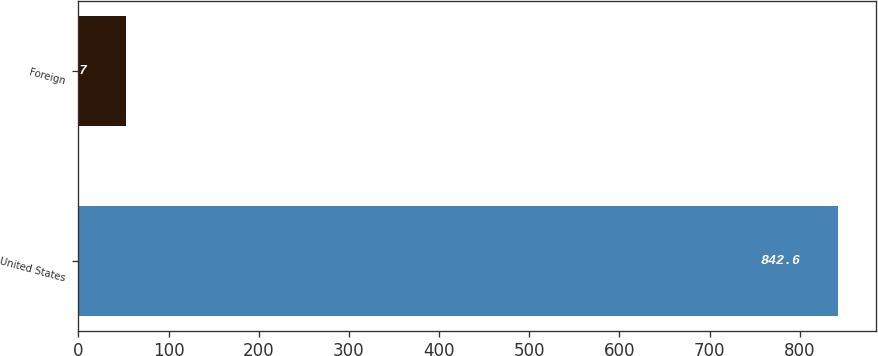Convert chart. <chart><loc_0><loc_0><loc_500><loc_500><bar_chart><fcel>United States<fcel>Foreign<nl><fcel>842.6<fcel>52.7<nl></chart> 